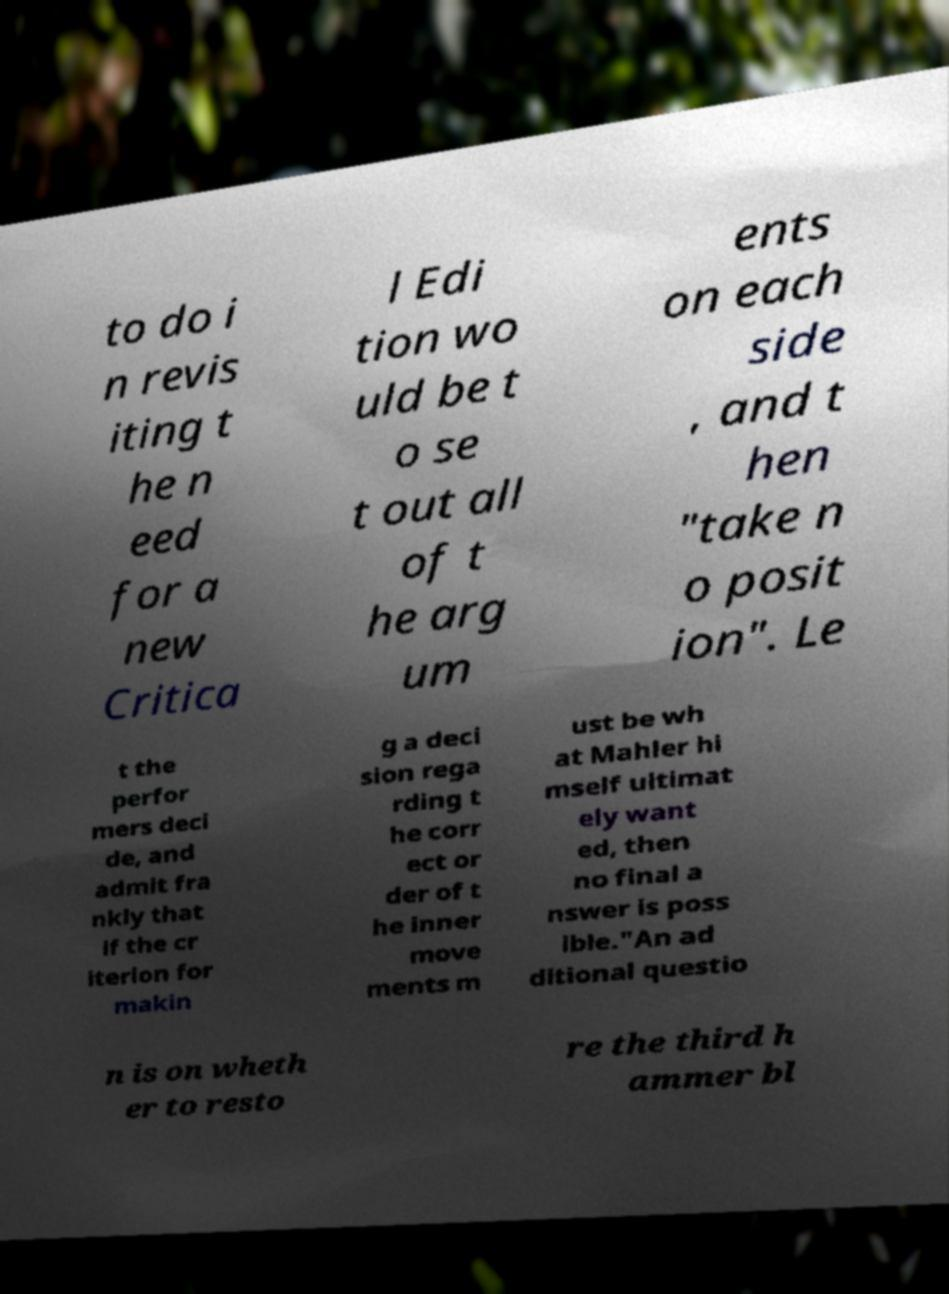What messages or text are displayed in this image? I need them in a readable, typed format. to do i n revis iting t he n eed for a new Critica l Edi tion wo uld be t o se t out all of t he arg um ents on each side , and t hen "take n o posit ion". Le t the perfor mers deci de, and admit fra nkly that if the cr iterion for makin g a deci sion rega rding t he corr ect or der of t he inner move ments m ust be wh at Mahler hi mself ultimat ely want ed, then no final a nswer is poss ible."An ad ditional questio n is on wheth er to resto re the third h ammer bl 